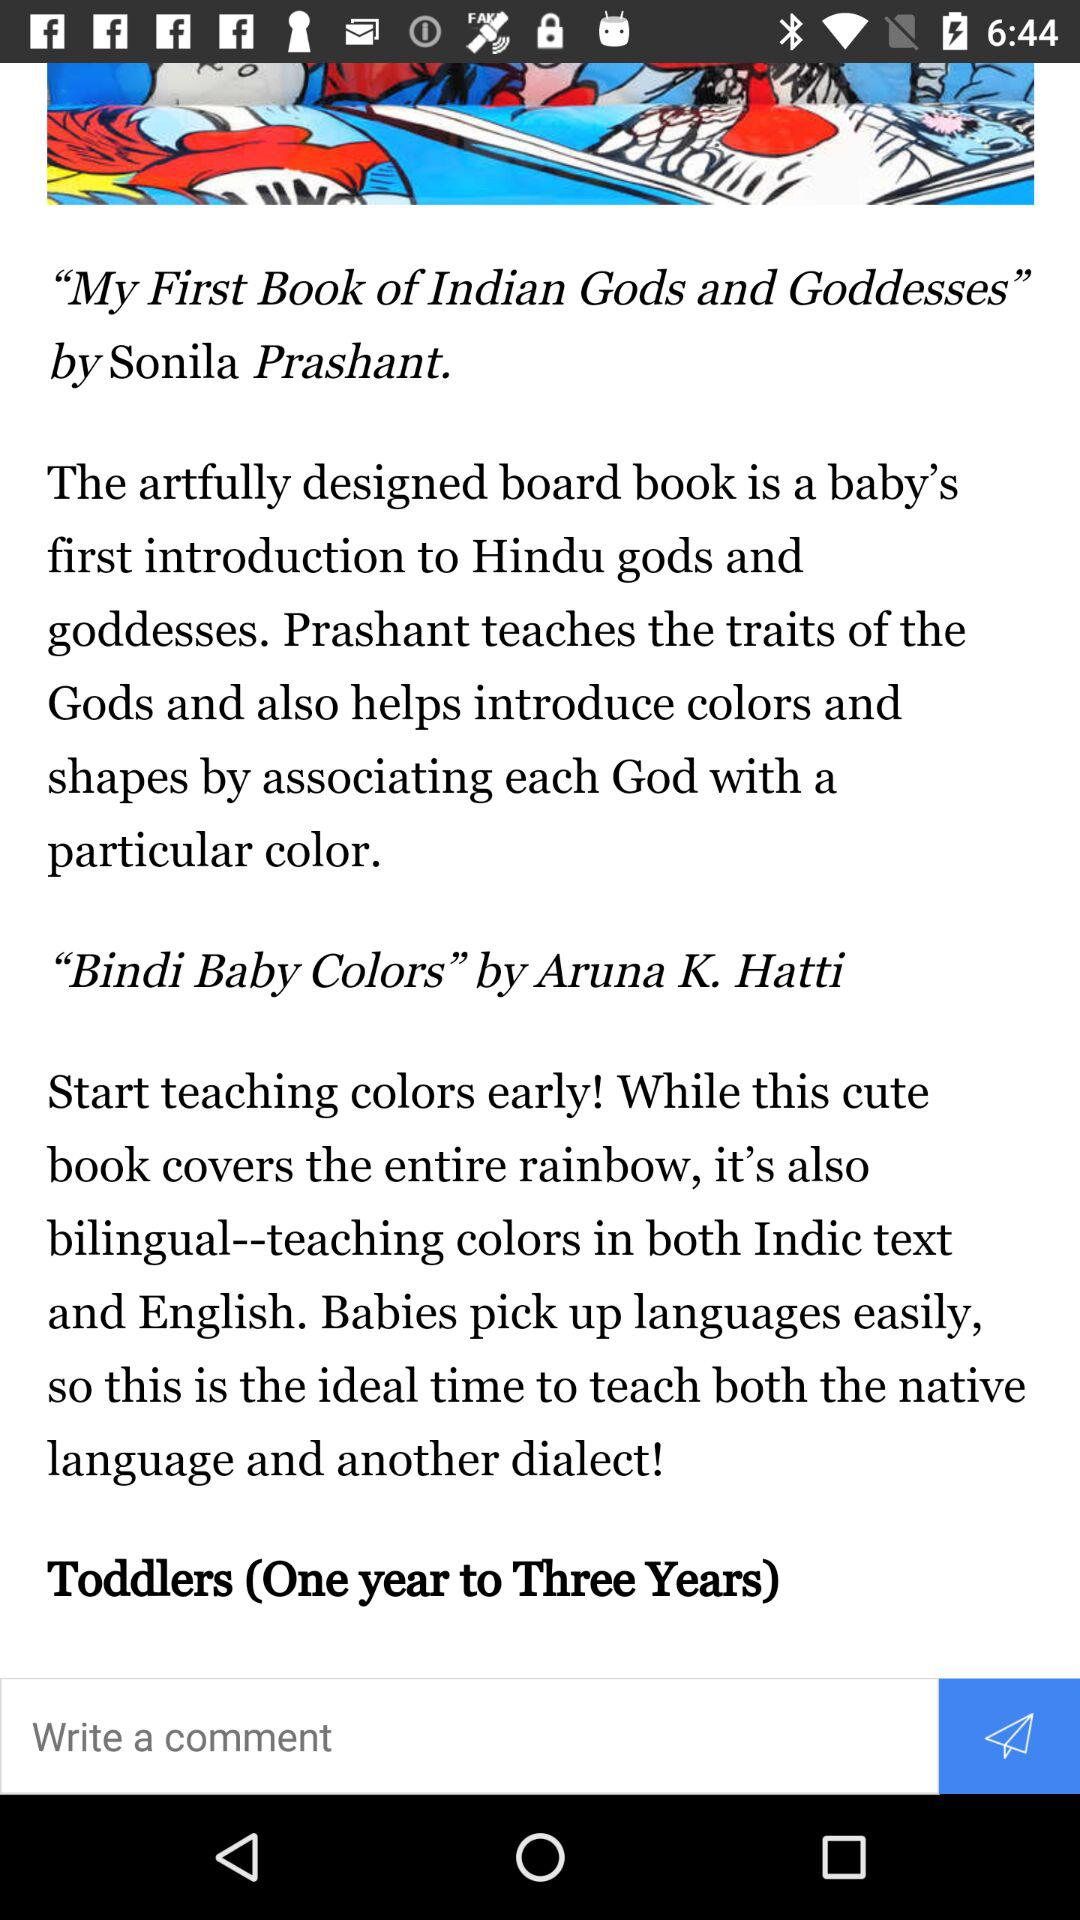Who is the writer of "Bindi Baby Colors"? The writer of "Bindi Baby Colors" is Aruna K. Hatti. 